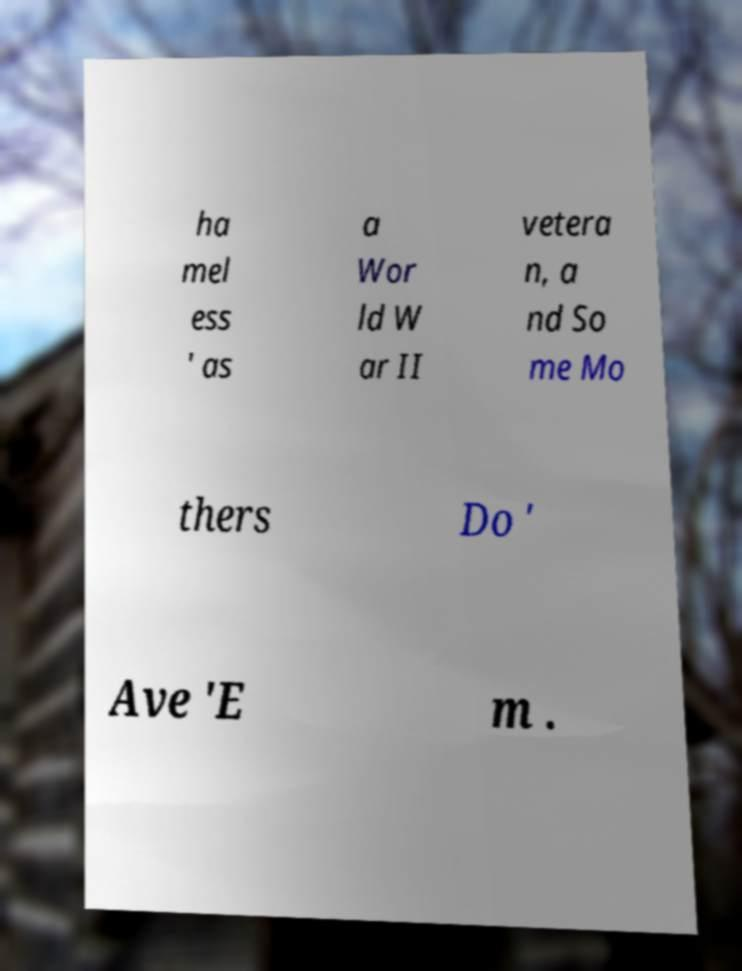Could you assist in decoding the text presented in this image and type it out clearly? ha mel ess ' as a Wor ld W ar II vetera n, a nd So me Mo thers Do ' Ave 'E m . 